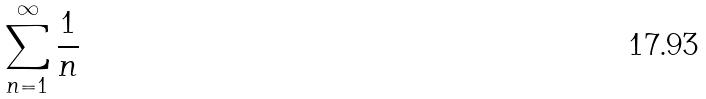Convert formula to latex. <formula><loc_0><loc_0><loc_500><loc_500>\sum _ { n = 1 } ^ { \infty } \frac { 1 } { n }</formula> 